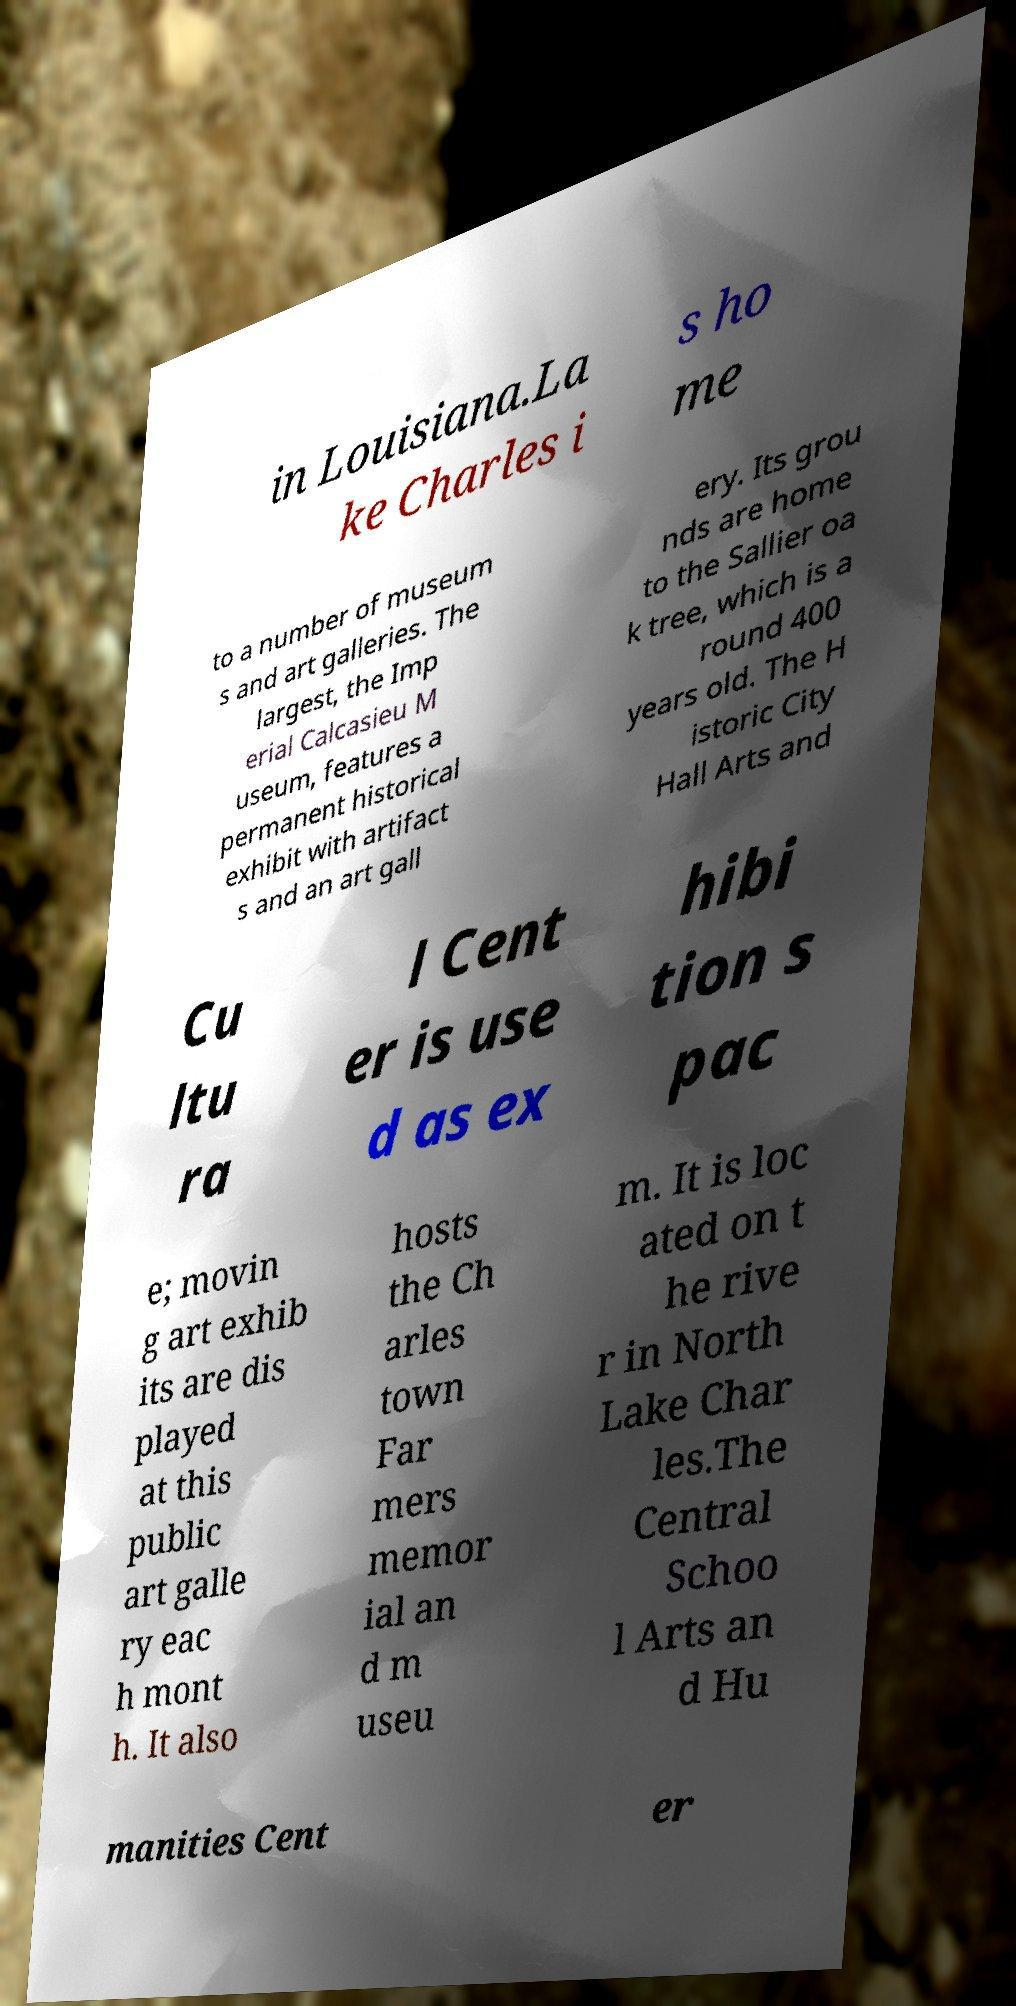Can you read and provide the text displayed in the image?This photo seems to have some interesting text. Can you extract and type it out for me? in Louisiana.La ke Charles i s ho me to a number of museum s and art galleries. The largest, the Imp erial Calcasieu M useum, features a permanent historical exhibit with artifact s and an art gall ery. Its grou nds are home to the Sallier oa k tree, which is a round 400 years old. The H istoric City Hall Arts and Cu ltu ra l Cent er is use d as ex hibi tion s pac e; movin g art exhib its are dis played at this public art galle ry eac h mont h. It also hosts the Ch arles town Far mers memor ial an d m useu m. It is loc ated on t he rive r in North Lake Char les.The Central Schoo l Arts an d Hu manities Cent er 